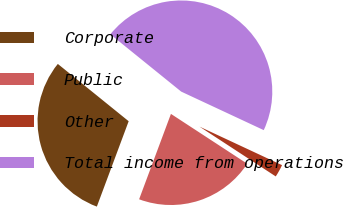Convert chart. <chart><loc_0><loc_0><loc_500><loc_500><pie_chart><fcel>Corporate<fcel>Public<fcel>Other<fcel>Total income from operations<nl><fcel>30.15%<fcel>21.47%<fcel>2.26%<fcel>46.13%<nl></chart> 